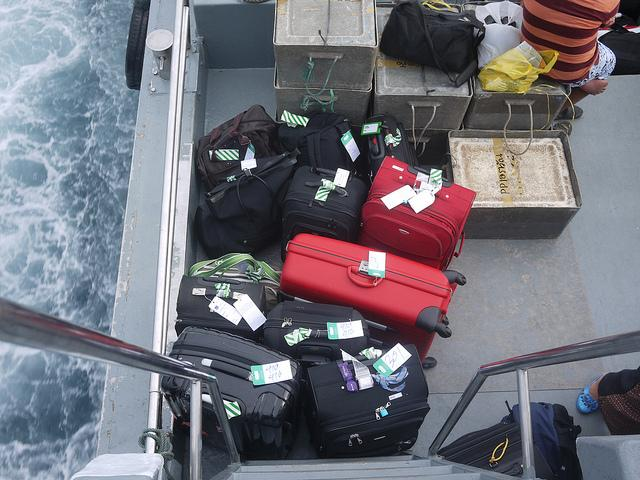How are bags identified here? Please explain your reasoning. tags. The luggage is all tagged. 